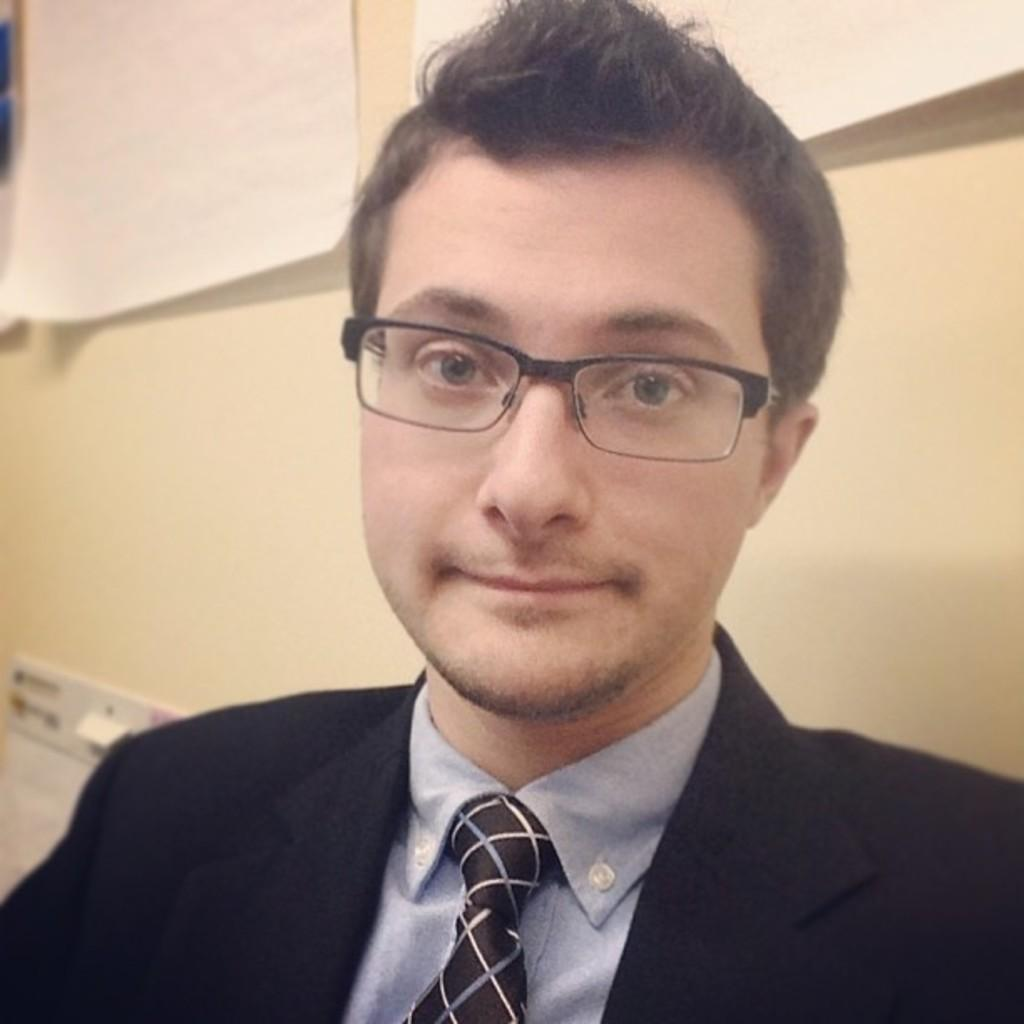Who or what is in the center of the image? There is a person in the center of the image. What can be seen in the background of the image? There is a wall and a switch board in the background of the image. Are there any objects related to documentation in the image? Yes, there are papers in the background of the image. What type of prose can be heard being recited by the person in the image? There is no indication in the image that the person is reciting any prose, so it cannot be determined from the picture. 